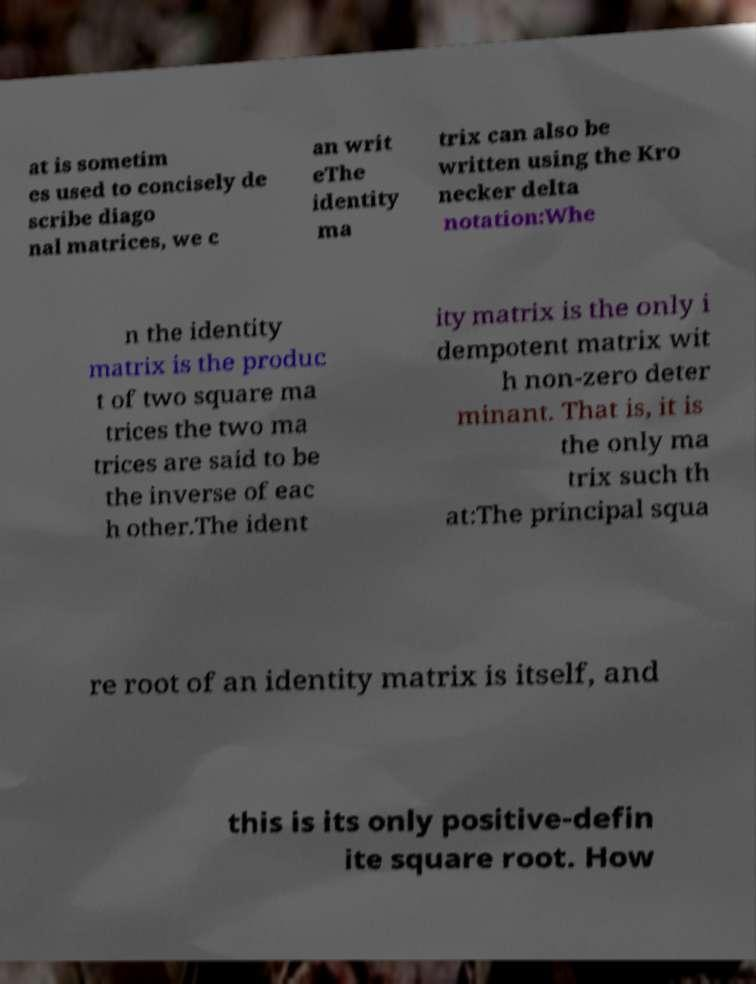I need the written content from this picture converted into text. Can you do that? at is sometim es used to concisely de scribe diago nal matrices, we c an writ eThe identity ma trix can also be written using the Kro necker delta notation:Whe n the identity matrix is the produc t of two square ma trices the two ma trices are said to be the inverse of eac h other.The ident ity matrix is the only i dempotent matrix wit h non-zero deter minant. That is, it is the only ma trix such th at:The principal squa re root of an identity matrix is itself, and this is its only positive-defin ite square root. How 